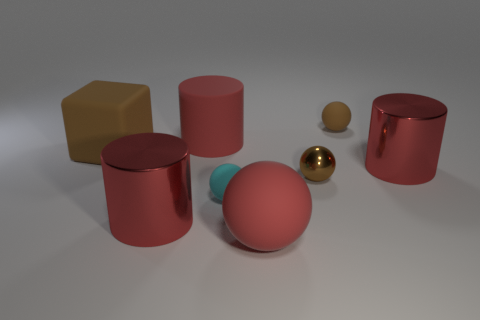How many red cylinders must be subtracted to get 1 red cylinders? 2 Add 2 rubber objects. How many objects exist? 10 Subtract all metallic cylinders. How many cylinders are left? 1 Subtract all shiny objects. Subtract all big metal objects. How many objects are left? 3 Add 5 brown objects. How many brown objects are left? 8 Add 2 big red matte cylinders. How many big red matte cylinders exist? 3 Subtract all cyan spheres. How many spheres are left? 3 Subtract 0 yellow cylinders. How many objects are left? 8 Subtract all cylinders. How many objects are left? 5 Subtract 2 spheres. How many spheres are left? 2 